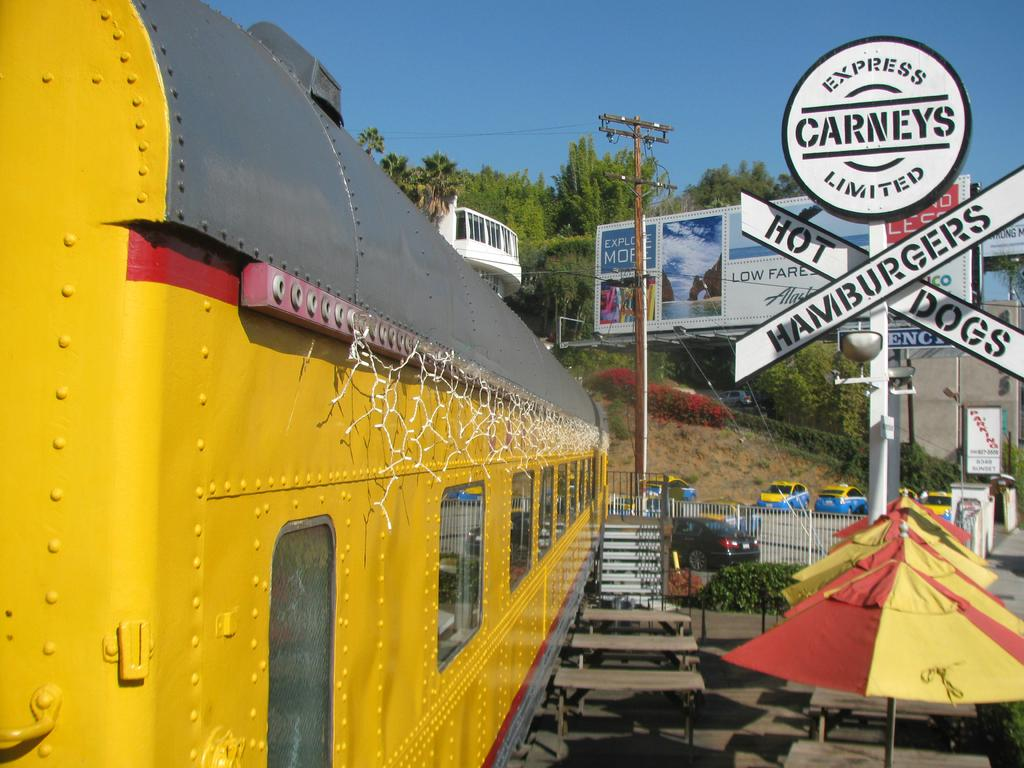What type of canteen is present in the image? There is a mobile canteen in the image. What type of seating is available in the image? There are benches in the image. Are there any architectural features in the image? Yes, there are steps and a railing in the image. What type of shelter is provided in the image? There are umbrellas in the image. What type of vegetation is present in the image? There are plants and trees in the image. What part of the natural environment is visible in the image? The sky is visible in the image. What type of structure is present in the image? There is a building in the image. What type of advertisement is present in the image? There is a hoarding in the image. What type of vehicles are present in the image? There are vehicles in the image. What type of signage is present in the image? There are boards in the image. What type of pole is present in the image? There is a pole in the image. What type of objects are present in the image? There are objects in the image. Can you describe the beggar's outfit in the image? There is no beggar present in the image. How does the self-awareness of the objects in the image affect their behavior? The objects in the image do not have self-awareness, so this question cannot be answered. 